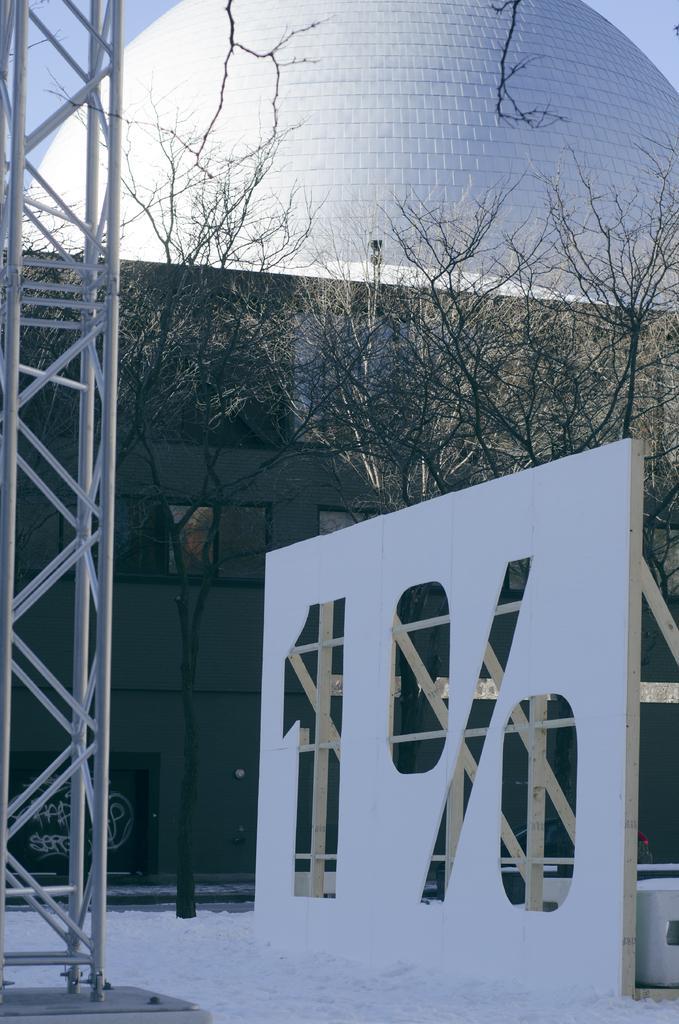Can you describe this image briefly? In this picture I can see a building and few trees and snow on the ground and I can see a cloudy sky and a pole on the side. 